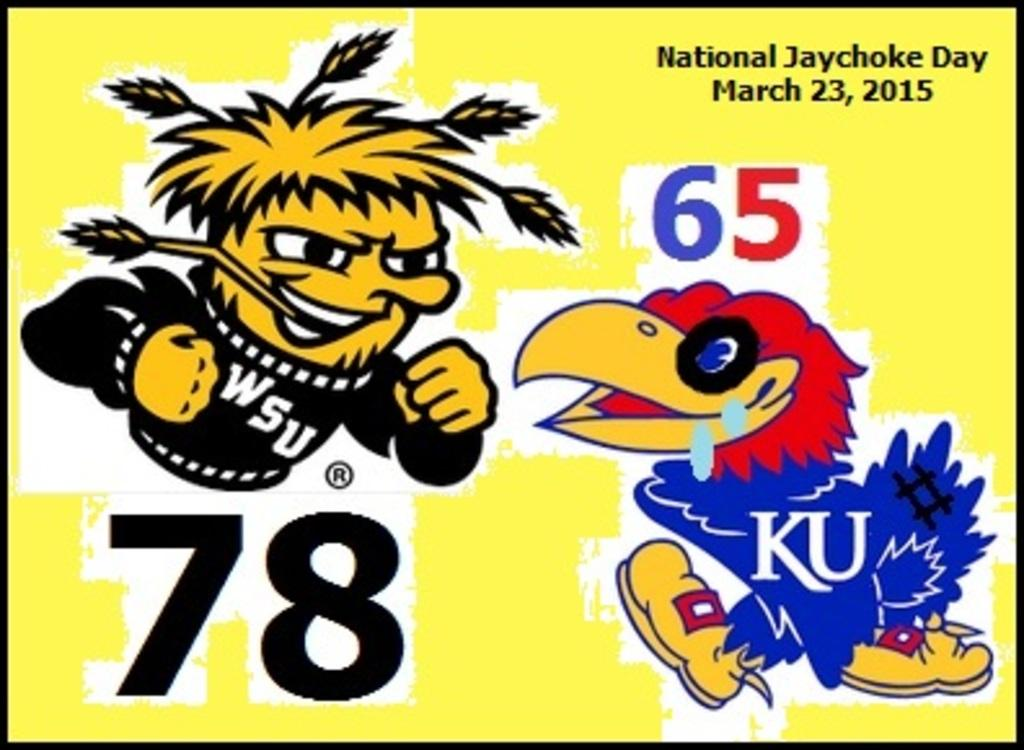What type of characters are depicted in the animation picture in the image? There is an animation picture of a person and a bird in the image. What is written in the image? There are numbers and words written in the image. What color is the background of the image? The background of the image is yellow. What type of sweater is the bird wearing in the image? There is no sweater present in the image, as it features animation pictures of a person and a bird. What songs can be heard playing in the background of the image? There is no audio component in the image, so it is not possible to determine what songs might be heard. 